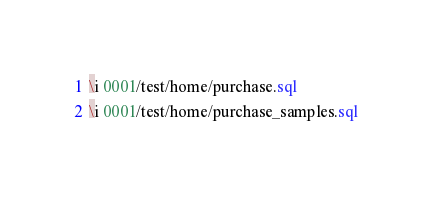<code> <loc_0><loc_0><loc_500><loc_500><_SQL_>\i 0001/test/home/purchase.sql
\i 0001/test/home/purchase_samples.sql
</code> 